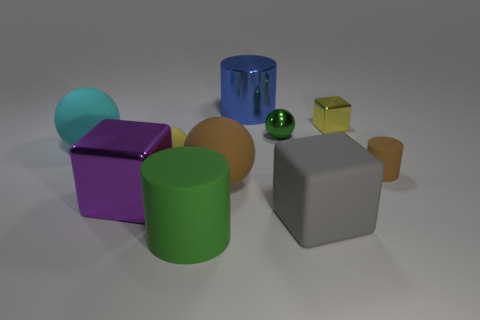Subtract all tiny yellow matte spheres. How many spheres are left? 3 Subtract all blue cylinders. How many cylinders are left? 2 Subtract all spheres. How many objects are left? 6 Subtract all purple cylinders. Subtract all blue cubes. How many cylinders are left? 3 Subtract all cyan cubes. Subtract all green balls. How many objects are left? 9 Add 1 large gray blocks. How many large gray blocks are left? 2 Add 5 brown cylinders. How many brown cylinders exist? 6 Subtract 0 green cubes. How many objects are left? 10 Subtract 3 balls. How many balls are left? 1 